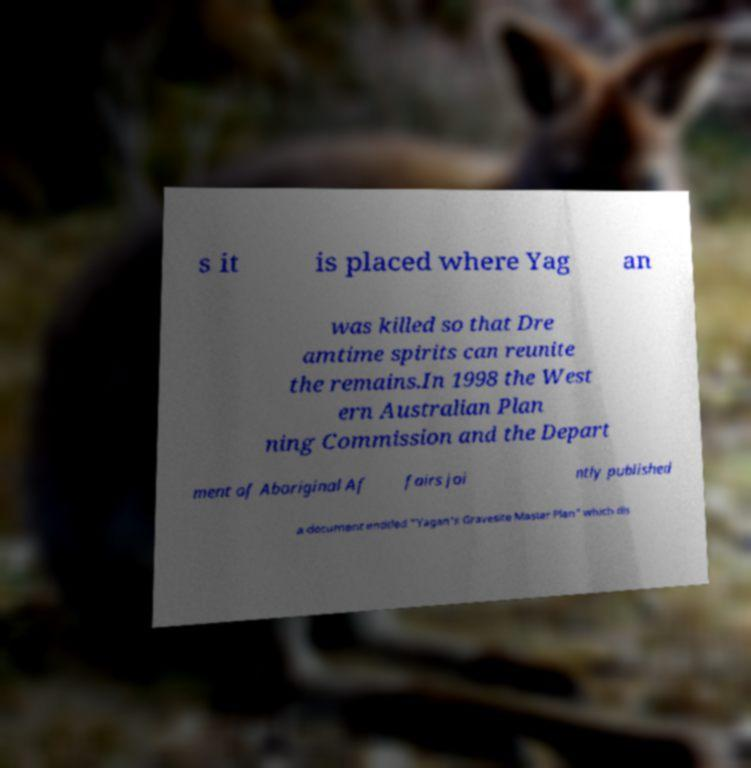Please read and relay the text visible in this image. What does it say? s it is placed where Yag an was killed so that Dre amtime spirits can reunite the remains.In 1998 the West ern Australian Plan ning Commission and the Depart ment of Aboriginal Af fairs joi ntly published a document entitled "Yagan's Gravesite Master Plan" which dis 